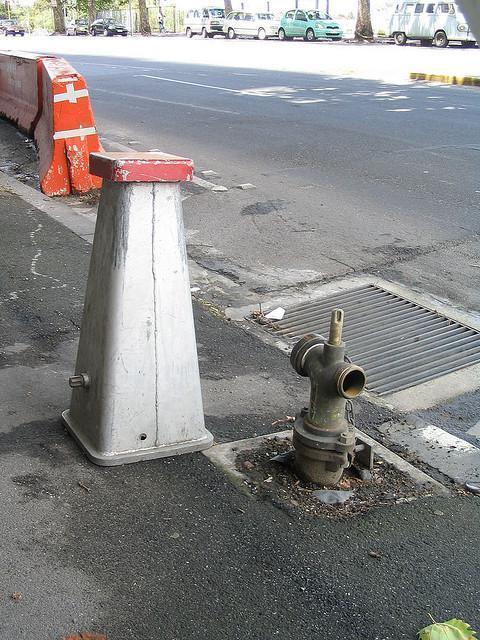How many cars?
Give a very brief answer. 7. 